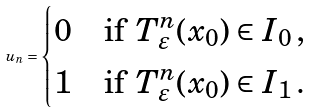<formula> <loc_0><loc_0><loc_500><loc_500>u _ { n } = \begin{cases} 0 & \text {if } T _ { \varepsilon } ^ { n } ( x _ { 0 } ) \in I _ { 0 } \, , \\ 1 & \text {if } T _ { \varepsilon } ^ { n } ( x _ { 0 } ) \in I _ { 1 } \, . \end{cases}</formula> 